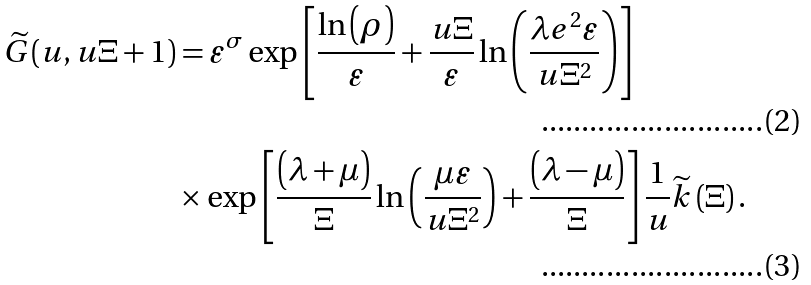Convert formula to latex. <formula><loc_0><loc_0><loc_500><loc_500>\widetilde { G } ( u , u \Xi + 1 ) & = \varepsilon ^ { \sigma } \exp \left [ \frac { \ln \left ( \rho \right ) } { \varepsilon } + \frac { u \Xi } { \varepsilon } \ln \left ( \frac { \lambda e ^ { 2 } \varepsilon } { u \Xi ^ { 2 } } \right ) \right ] \\ & \times \exp \left [ \frac { \left ( \lambda + \mu \right ) } { \Xi } \ln \left ( \frac { \mu \varepsilon } { u \Xi ^ { 2 } } \right ) + \frac { \left ( \lambda - \mu \right ) } { \Xi } \right ] \frac { 1 } { u } \widetilde { k } \left ( \Xi \right ) .</formula> 